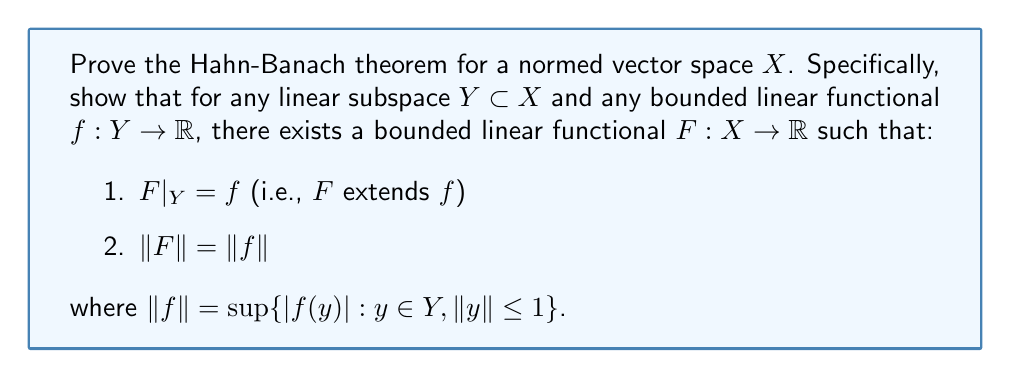Could you help me with this problem? To prove the Hahn-Banach theorem for a normed vector space, we'll follow these steps:

1. Start with the Hahn-Banach theorem for real vector spaces:
   Let $p: X \to \mathbb{R}$ be a sublinear functional, $Y \subset X$ a subspace, and $g: Y \to \mathbb{R}$ a linear functional such that $g(y) \leq p(y)$ for all $y \in Y$. Then there exists a linear extension $G: X \to \mathbb{R}$ of $g$ such that $G(x) \leq p(x)$ for all $x \in X$.

2. Define a sublinear functional $p: X \to \mathbb{R}$ by $p(x) = \|f\| \cdot \|x\|$.

3. Verify that $p$ is indeed sublinear:
   a) $p(\alpha x) = \|f\| \cdot \|\alpha x\| = |\alpha| \cdot \|f\| \cdot \|x\| = |\alpha| \cdot p(x)$ for all $\alpha \in \mathbb{R}$
   b) $p(x + y) = \|f\| \cdot \|x + y\| \leq \|f\| \cdot (\|x\| + \|y\|) = p(x) + p(y)$

4. Show that $f(y) \leq p(y)$ for all $y \in Y$:
   $|f(y)| \leq \|f\| \cdot \|y\|$ by definition of $\|f\|$, so $-\|f\| \cdot \|y\| \leq f(y) \leq \|f\| \cdot \|y\|$

5. Apply the Hahn-Banach theorem for real vector spaces to obtain a linear extension $F: X \to \mathbb{R}$ of $f$ such that $F(x) \leq p(x)$ for all $x \in X$.

6. Show that $-F(x) \leq p(-x) = p(x)$ for all $x \in X$:
   $-F(x) = F(-x) \leq p(-x) = \|f\| \cdot \|-x\| = \|f\| \cdot \|x\| = p(x)$

7. Combine the results from steps 5 and 6 to conclude that $|F(x)| \leq p(x) = \|f\| \cdot \|x\|$ for all $x \in X$.

8. Show that $\|F\| \leq \|f\|$:
   $\|F\| = \sup\{|F(x)| : x \in X, \|x\| \leq 1\} \leq \sup\{\|f\| \cdot \|x\| : x \in X, \|x\| \leq 1\} = \|f\|$

9. Since $F$ extends $f$, we have $\|F\| \geq \|f\|$. Combined with step 8, we conclude that $\|F\| = \|f\|$.

This completes the proof of the Hahn-Banach theorem for normed vector spaces.
Answer: The Hahn-Banach theorem for normed vector spaces is proved. We have shown that for any linear subspace $Y \subset X$ and any bounded linear functional $f: Y \to \mathbb{R}$, there exists a bounded linear functional $F: X \to \mathbb{R}$ such that:

1. $F|_Y = f$ (i.e., $F$ extends $f$)
2. $\|F\| = \|f\|$

The key steps were applying the Hahn-Banach theorem for real vector spaces to a carefully chosen sublinear functional $p(x) = \|f\| \cdot \|x\|$, and then showing that the resulting extension $F$ satisfies the required properties. 